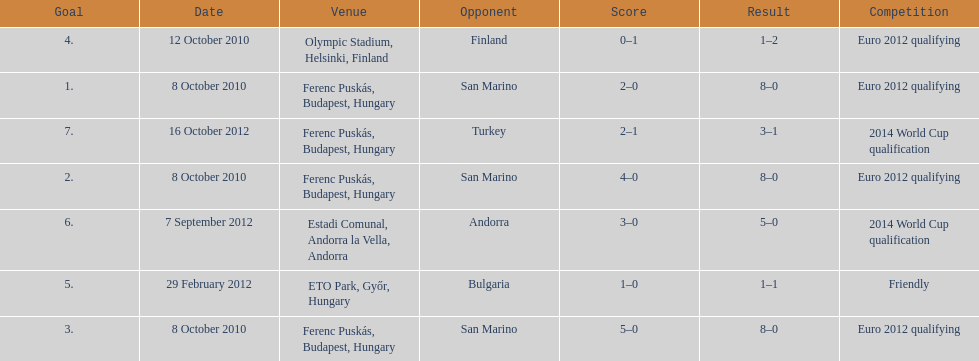Write the full table. {'header': ['Goal', 'Date', 'Venue', 'Opponent', 'Score', 'Result', 'Competition'], 'rows': [['4.', '12 October 2010', 'Olympic Stadium, Helsinki, Finland', 'Finland', '0–1', '1–2', 'Euro 2012 qualifying'], ['1.', '8 October 2010', 'Ferenc Puskás, Budapest, Hungary', 'San Marino', '2–0', '8–0', 'Euro 2012 qualifying'], ['7.', '16 October 2012', 'Ferenc Puskás, Budapest, Hungary', 'Turkey', '2–1', '3–1', '2014 World Cup qualification'], ['2.', '8 October 2010', 'Ferenc Puskás, Budapest, Hungary', 'San Marino', '4–0', '8–0', 'Euro 2012 qualifying'], ['6.', '7 September 2012', 'Estadi Comunal, Andorra la Vella, Andorra', 'Andorra', '3–0', '5–0', '2014 World Cup qualification'], ['5.', '29 February 2012', 'ETO Park, Győr, Hungary', 'Bulgaria', '1–0', '1–1', 'Friendly'], ['3.', '8 October 2010', 'Ferenc Puskás, Budapest, Hungary', 'San Marino', '5–0', '8–0', 'Euro 2012 qualifying']]} Szalai scored only one more international goal against all other countries put together than he did against what one country? San Marino. 